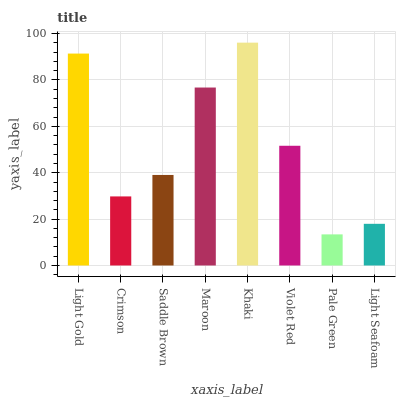Is Pale Green the minimum?
Answer yes or no. Yes. Is Khaki the maximum?
Answer yes or no. Yes. Is Crimson the minimum?
Answer yes or no. No. Is Crimson the maximum?
Answer yes or no. No. Is Light Gold greater than Crimson?
Answer yes or no. Yes. Is Crimson less than Light Gold?
Answer yes or no. Yes. Is Crimson greater than Light Gold?
Answer yes or no. No. Is Light Gold less than Crimson?
Answer yes or no. No. Is Violet Red the high median?
Answer yes or no. Yes. Is Saddle Brown the low median?
Answer yes or no. Yes. Is Saddle Brown the high median?
Answer yes or no. No. Is Light Gold the low median?
Answer yes or no. No. 